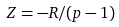<formula> <loc_0><loc_0><loc_500><loc_500>Z = - R / ( p - 1 )</formula> 